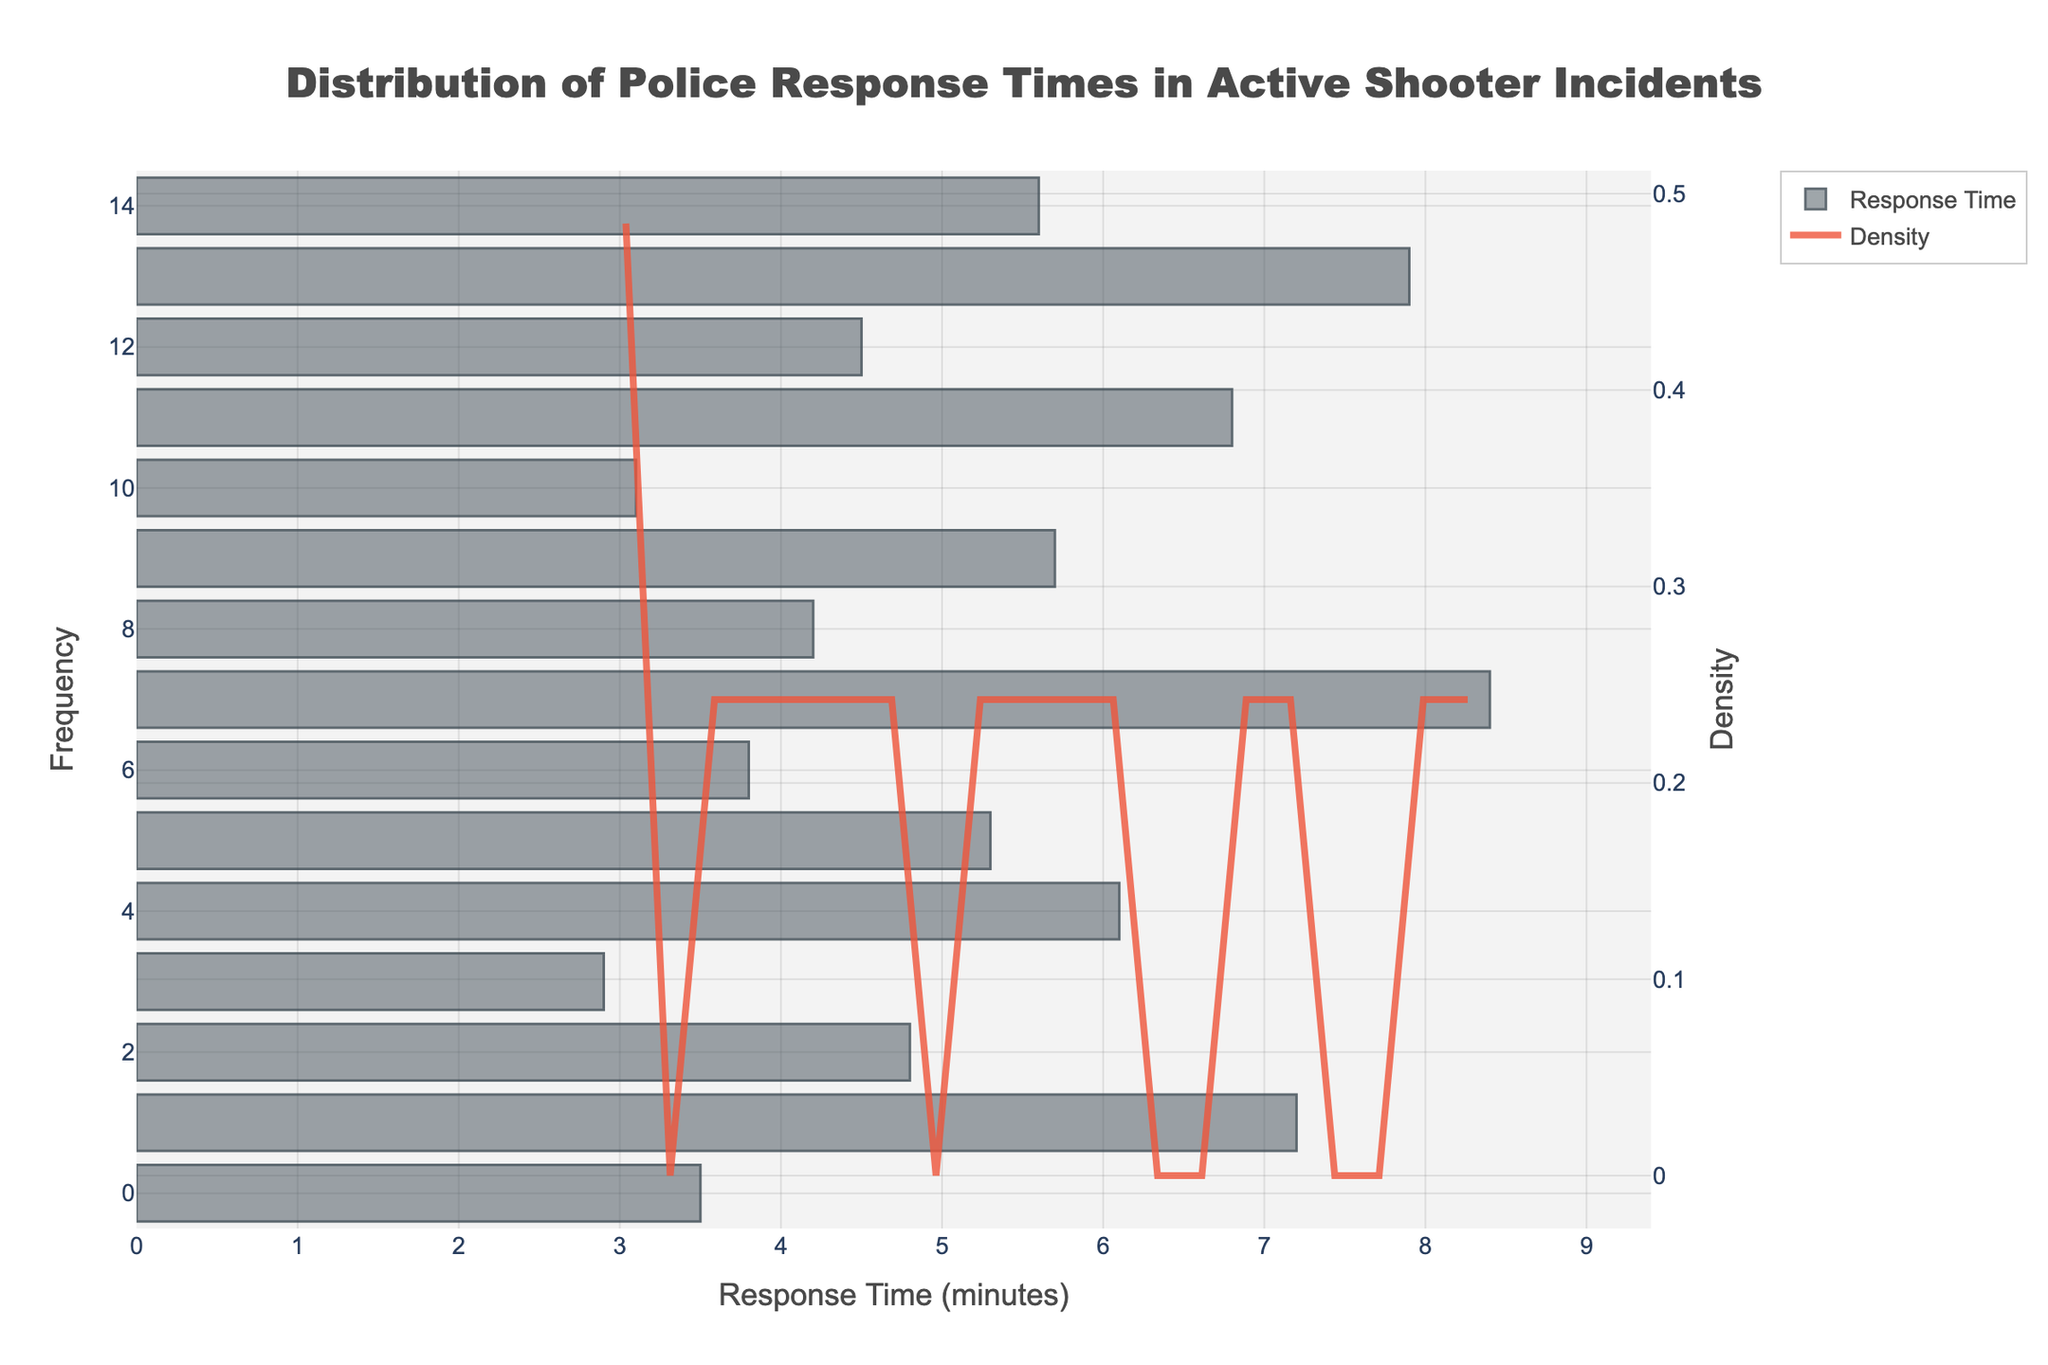what's the title of the figure? The title of a figure is typically located at the top, often in larger or bold text. It provides a summary of what the figure represents. In this case, it states "Distribution of Police Response Times in Active Shooter Incidents."
Answer: Distribution of Police Response Times in Active Shooter Incidents what do the bars in the histogram represent? The bars in the histogram represent the frequency of police response times measured in minutes during active shooter incidents. Each bar's height corresponds to how many incidents had a response time falling within a specific range.
Answer: Frequency of response times what do the different colors in the figure indicate? The bars representing the response times are colored in a shade of gray with some transparency, while the KDE line is a shade of red with opacity, making it stand out.
Answer: Gray for bars, red for KDE how many data points are represented in the histogram? Each bar represents a data point, and by counting the number of bars, we can determine there are 15 data points representing the response times at different incidents.
Answer: 15 what is the approximate range of response times shown in the histogram? By looking at the x-axis which indicates response time in minutes, and observing where the bars start and end, we see the range is from around 2.9 minutes to 8.4 minutes.
Answer: 2.9 to 8.4 minutes which response time appears to have the highest frequency? The response time with the highest frequency is indicated by the tallest bar in the histogram. By visually examining the bar heights, we observe that a response time around 4-5 minutes has a higher frequency.
Answer: Around 4-5 minutes what is the shape of the KDE curve, and what does it indicate? The KDE curve has peaks and troughs indicating the density of response times within certain ranges. A peak around 4-5 minutes implies a higher density of incidents within this response time range, while troughs indicate lower density.
Answer: Peak at 4-5 minutes, denser there how does the highest frequency response time compare to the density peak on the KDE curve? The highest frequency bar in the histogram and the peak on the KDE curve both occur around the 4-5 minute range, indicating consistency between the histogram and KDE in identifying the most common response time.
Answer: Both around 4-5 minutes what's the approximate average response time based on the data points? To find the average response time, sum up all individual response times and divide by the number of data points. (3.5 + 7.2 + 4.8 + 2.9 + 6.1 + 5.3 + 3.8 + 8.4 + 4.2 + 5.7 + 3.1 + 6.8 + 4.5 + 7.9 + 5.6) / 15 = 5.16 minutes.
Answer: 5.16 minutes does the KDE curve provide additional insight beyond the histogram? If yes, what? Yes, the KDE curve smooths out the data to provide a continuous estimate of density, helping identify trends and patterns not as obvious in the histogram, such as smaller peaks or troughs in response time distribution.
Answer: Continuous trend insights 